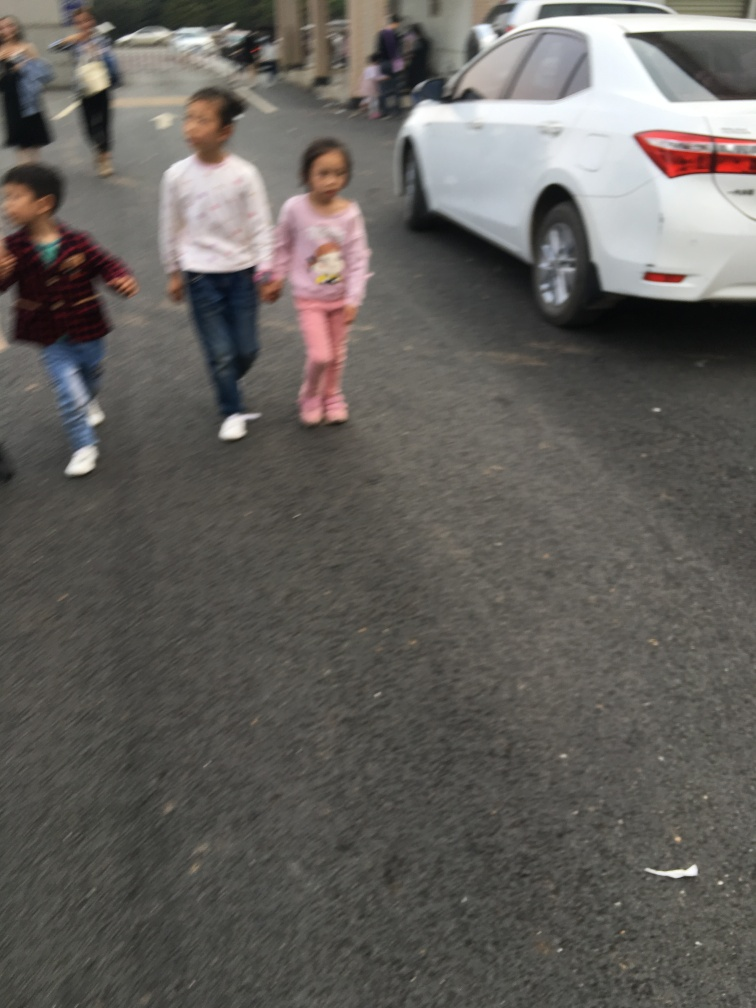What suggestions would you have for improving a photograph like this? To improve a photograph like this, I would suggest using a faster shutter speed to reduce motion blur. A higher resolution setting would capture more details, and focusing more carefully on the subjects could make them stand out better. The composition could be improved by positioning the subjects intentionally within the frame, applying the rule of thirds, and eliminating unnecessary space at the top of the image to create a balanced and engaging photograph. 